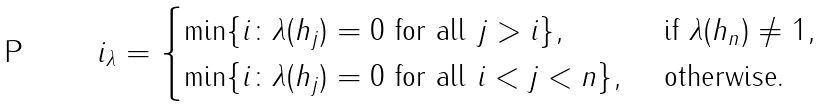<formula> <loc_0><loc_0><loc_500><loc_500>i _ { \lambda } = \begin{cases} \min \{ i \colon \lambda ( h _ { j } ) = 0 \text { for all } j > i \} , & \text { if } \lambda ( h _ { n } ) \ne 1 , \\ \min \{ i \colon \lambda ( h _ { j } ) = 0 \text { for all } i < j < n \} , & \text { otherwise} . \end{cases}</formula> 